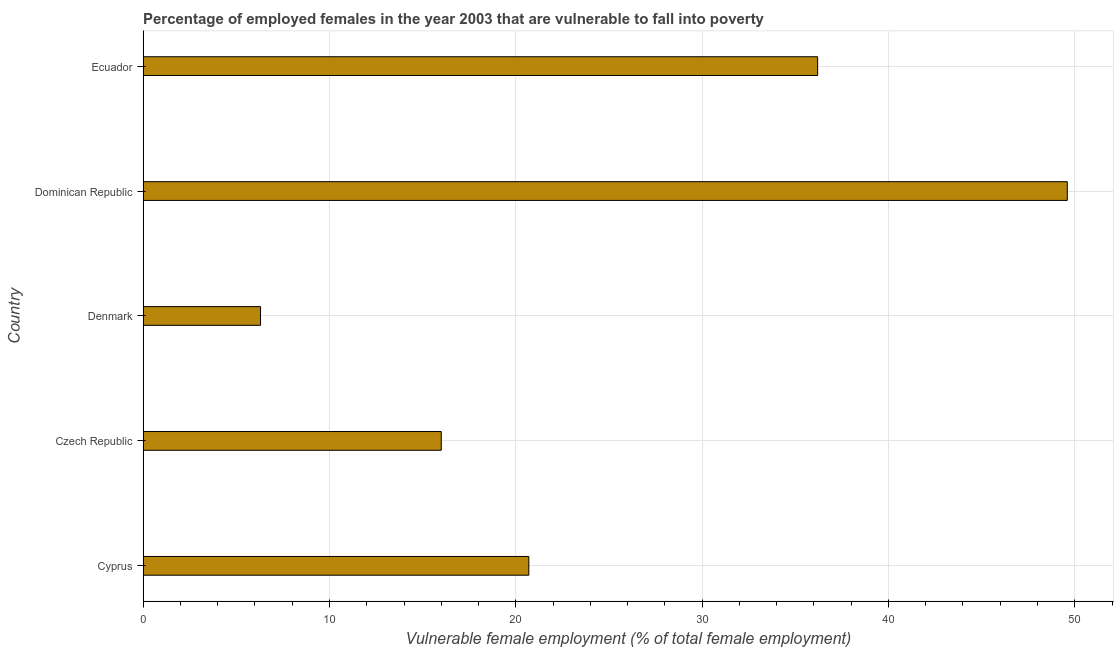Does the graph contain any zero values?
Keep it short and to the point. No. What is the title of the graph?
Offer a very short reply. Percentage of employed females in the year 2003 that are vulnerable to fall into poverty. What is the label or title of the X-axis?
Offer a terse response. Vulnerable female employment (% of total female employment). What is the label or title of the Y-axis?
Ensure brevity in your answer.  Country. Across all countries, what is the maximum percentage of employed females who are vulnerable to fall into poverty?
Provide a succinct answer. 49.6. Across all countries, what is the minimum percentage of employed females who are vulnerable to fall into poverty?
Offer a terse response. 6.3. In which country was the percentage of employed females who are vulnerable to fall into poverty maximum?
Your answer should be compact. Dominican Republic. In which country was the percentage of employed females who are vulnerable to fall into poverty minimum?
Offer a very short reply. Denmark. What is the sum of the percentage of employed females who are vulnerable to fall into poverty?
Offer a very short reply. 128.8. What is the difference between the percentage of employed females who are vulnerable to fall into poverty in Denmark and Ecuador?
Your response must be concise. -29.9. What is the average percentage of employed females who are vulnerable to fall into poverty per country?
Offer a very short reply. 25.76. What is the median percentage of employed females who are vulnerable to fall into poverty?
Give a very brief answer. 20.7. What is the ratio of the percentage of employed females who are vulnerable to fall into poverty in Dominican Republic to that in Ecuador?
Offer a terse response. 1.37. Is the sum of the percentage of employed females who are vulnerable to fall into poverty in Cyprus and Czech Republic greater than the maximum percentage of employed females who are vulnerable to fall into poverty across all countries?
Provide a succinct answer. No. What is the difference between the highest and the lowest percentage of employed females who are vulnerable to fall into poverty?
Keep it short and to the point. 43.3. How many countries are there in the graph?
Give a very brief answer. 5. What is the difference between two consecutive major ticks on the X-axis?
Offer a very short reply. 10. What is the Vulnerable female employment (% of total female employment) in Cyprus?
Keep it short and to the point. 20.7. What is the Vulnerable female employment (% of total female employment) of Czech Republic?
Ensure brevity in your answer.  16. What is the Vulnerable female employment (% of total female employment) in Denmark?
Your answer should be very brief. 6.3. What is the Vulnerable female employment (% of total female employment) in Dominican Republic?
Offer a terse response. 49.6. What is the Vulnerable female employment (% of total female employment) in Ecuador?
Provide a succinct answer. 36.2. What is the difference between the Vulnerable female employment (% of total female employment) in Cyprus and Dominican Republic?
Your answer should be compact. -28.9. What is the difference between the Vulnerable female employment (% of total female employment) in Cyprus and Ecuador?
Provide a short and direct response. -15.5. What is the difference between the Vulnerable female employment (% of total female employment) in Czech Republic and Denmark?
Provide a succinct answer. 9.7. What is the difference between the Vulnerable female employment (% of total female employment) in Czech Republic and Dominican Republic?
Your answer should be compact. -33.6. What is the difference between the Vulnerable female employment (% of total female employment) in Czech Republic and Ecuador?
Offer a very short reply. -20.2. What is the difference between the Vulnerable female employment (% of total female employment) in Denmark and Dominican Republic?
Give a very brief answer. -43.3. What is the difference between the Vulnerable female employment (% of total female employment) in Denmark and Ecuador?
Your answer should be very brief. -29.9. What is the ratio of the Vulnerable female employment (% of total female employment) in Cyprus to that in Czech Republic?
Provide a succinct answer. 1.29. What is the ratio of the Vulnerable female employment (% of total female employment) in Cyprus to that in Denmark?
Your answer should be very brief. 3.29. What is the ratio of the Vulnerable female employment (% of total female employment) in Cyprus to that in Dominican Republic?
Offer a very short reply. 0.42. What is the ratio of the Vulnerable female employment (% of total female employment) in Cyprus to that in Ecuador?
Your response must be concise. 0.57. What is the ratio of the Vulnerable female employment (% of total female employment) in Czech Republic to that in Denmark?
Provide a succinct answer. 2.54. What is the ratio of the Vulnerable female employment (% of total female employment) in Czech Republic to that in Dominican Republic?
Your response must be concise. 0.32. What is the ratio of the Vulnerable female employment (% of total female employment) in Czech Republic to that in Ecuador?
Give a very brief answer. 0.44. What is the ratio of the Vulnerable female employment (% of total female employment) in Denmark to that in Dominican Republic?
Offer a very short reply. 0.13. What is the ratio of the Vulnerable female employment (% of total female employment) in Denmark to that in Ecuador?
Offer a terse response. 0.17. What is the ratio of the Vulnerable female employment (% of total female employment) in Dominican Republic to that in Ecuador?
Offer a very short reply. 1.37. 